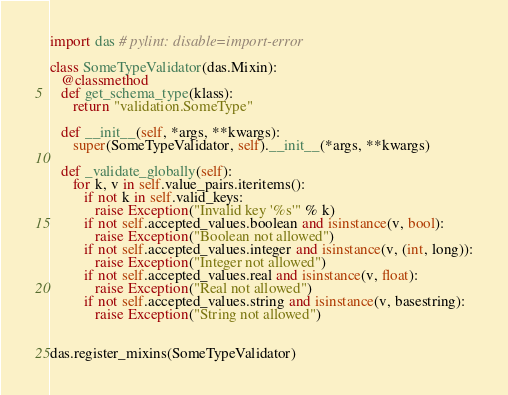Convert code to text. <code><loc_0><loc_0><loc_500><loc_500><_Python_>import das # pylint: disable=import-error

class SomeTypeValidator(das.Mixin):
   @classmethod
   def get_schema_type(klass):
      return "validation.SomeType"

   def __init__(self, *args, **kwargs):
      super(SomeTypeValidator, self).__init__(*args, **kwargs)

   def _validate_globally(self):
      for k, v in self.value_pairs.iteritems():
         if not k in self.valid_keys:
            raise Exception("Invalid key '%s'" % k)
         if not self.accepted_values.boolean and isinstance(v, bool):
            raise Exception("Boolean not allowed")
         if not self.accepted_values.integer and isinstance(v, (int, long)):
            raise Exception("Integer not allowed")
         if not self.accepted_values.real and isinstance(v, float):
            raise Exception("Real not allowed")
         if not self.accepted_values.string and isinstance(v, basestring):
            raise Exception("String not allowed")


das.register_mixins(SomeTypeValidator)
</code> 